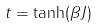<formula> <loc_0><loc_0><loc_500><loc_500>t = \tanh ( \beta J ) \,</formula> 